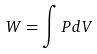<formula> <loc_0><loc_0><loc_500><loc_500>W = \int P d V</formula> 